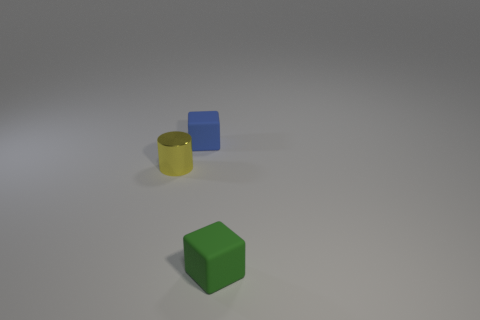Add 2 green matte objects. How many objects exist? 5 Subtract all cylinders. How many objects are left? 2 Add 3 cylinders. How many cylinders exist? 4 Subtract 0 brown spheres. How many objects are left? 3 Subtract all small cylinders. Subtract all shiny things. How many objects are left? 1 Add 3 yellow metallic objects. How many yellow metallic objects are left? 4 